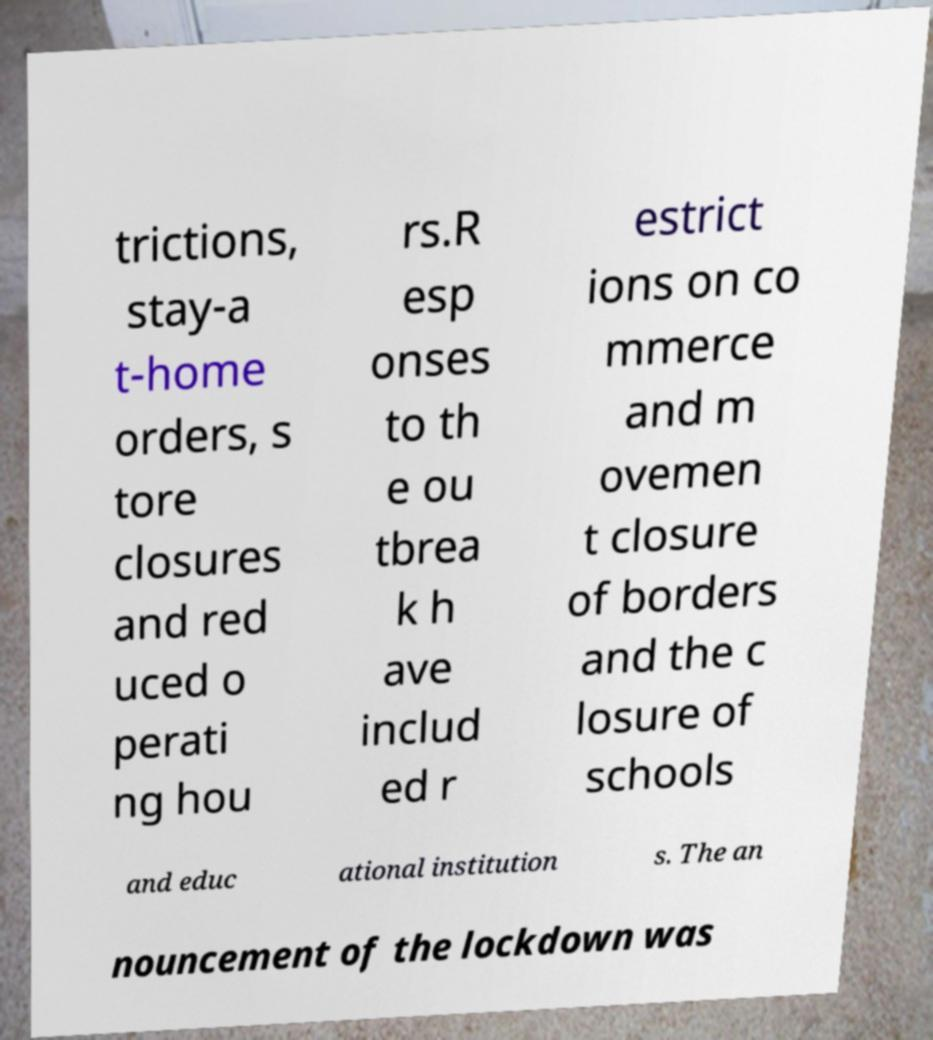Could you extract and type out the text from this image? trictions, stay-a t-home orders, s tore closures and red uced o perati ng hou rs.R esp onses to th e ou tbrea k h ave includ ed r estrict ions on co mmerce and m ovemen t closure of borders and the c losure of schools and educ ational institution s. The an nouncement of the lockdown was 